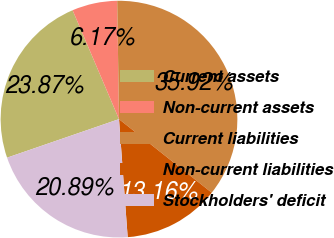<chart> <loc_0><loc_0><loc_500><loc_500><pie_chart><fcel>Current assets<fcel>Non-current assets<fcel>Current liabilities<fcel>Non-current liabilities<fcel>Stockholders' deficit<nl><fcel>23.87%<fcel>6.17%<fcel>35.92%<fcel>13.16%<fcel>20.89%<nl></chart> 